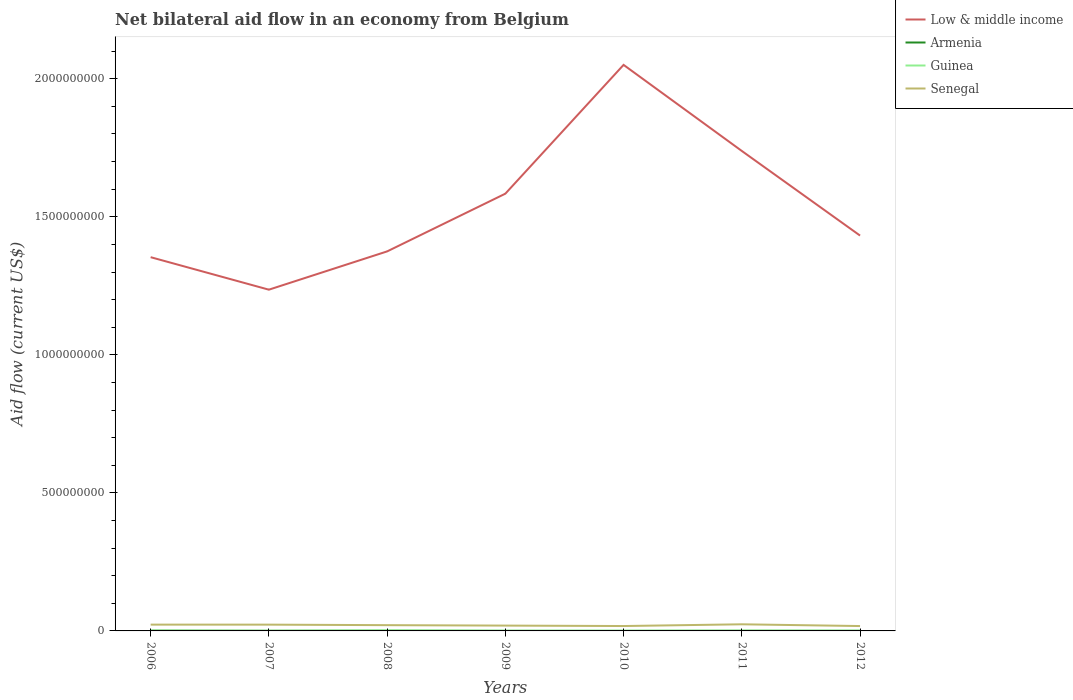Is the number of lines equal to the number of legend labels?
Ensure brevity in your answer.  Yes. Across all years, what is the maximum net bilateral aid flow in Armenia?
Your response must be concise. 3.00e+04. In which year was the net bilateral aid flow in Armenia maximum?
Make the answer very short. 2010. What is the total net bilateral aid flow in Senegal in the graph?
Your answer should be compact. 5.06e+06. What is the difference between the highest and the second highest net bilateral aid flow in Armenia?
Offer a terse response. 9.20e+05. What is the difference between the highest and the lowest net bilateral aid flow in Guinea?
Provide a succinct answer. 3. Is the net bilateral aid flow in Armenia strictly greater than the net bilateral aid flow in Low & middle income over the years?
Your answer should be very brief. Yes. How many lines are there?
Offer a terse response. 4. How many legend labels are there?
Offer a terse response. 4. What is the title of the graph?
Your answer should be compact. Net bilateral aid flow in an economy from Belgium. What is the label or title of the X-axis?
Make the answer very short. Years. What is the Aid flow (current US$) of Low & middle income in 2006?
Provide a short and direct response. 1.35e+09. What is the Aid flow (current US$) of Armenia in 2006?
Offer a terse response. 9.50e+05. What is the Aid flow (current US$) of Guinea in 2006?
Your answer should be compact. 1.53e+06. What is the Aid flow (current US$) in Senegal in 2006?
Make the answer very short. 2.28e+07. What is the Aid flow (current US$) of Low & middle income in 2007?
Make the answer very short. 1.24e+09. What is the Aid flow (current US$) in Armenia in 2007?
Your response must be concise. 3.70e+05. What is the Aid flow (current US$) in Guinea in 2007?
Give a very brief answer. 9.20e+05. What is the Aid flow (current US$) in Senegal in 2007?
Your response must be concise. 2.28e+07. What is the Aid flow (current US$) in Low & middle income in 2008?
Give a very brief answer. 1.37e+09. What is the Aid flow (current US$) in Armenia in 2008?
Give a very brief answer. 6.50e+05. What is the Aid flow (current US$) in Guinea in 2008?
Ensure brevity in your answer.  2.24e+06. What is the Aid flow (current US$) in Senegal in 2008?
Provide a succinct answer. 2.09e+07. What is the Aid flow (current US$) of Low & middle income in 2009?
Provide a succinct answer. 1.58e+09. What is the Aid flow (current US$) in Guinea in 2009?
Make the answer very short. 1.15e+06. What is the Aid flow (current US$) of Senegal in 2009?
Your response must be concise. 1.93e+07. What is the Aid flow (current US$) in Low & middle income in 2010?
Offer a very short reply. 2.05e+09. What is the Aid flow (current US$) in Armenia in 2010?
Make the answer very short. 3.00e+04. What is the Aid flow (current US$) of Guinea in 2010?
Keep it short and to the point. 1.05e+06. What is the Aid flow (current US$) in Senegal in 2010?
Give a very brief answer. 1.77e+07. What is the Aid flow (current US$) in Low & middle income in 2011?
Offer a terse response. 1.74e+09. What is the Aid flow (current US$) in Armenia in 2011?
Your response must be concise. 3.70e+05. What is the Aid flow (current US$) in Guinea in 2011?
Your answer should be very brief. 1.47e+06. What is the Aid flow (current US$) in Senegal in 2011?
Your response must be concise. 2.40e+07. What is the Aid flow (current US$) in Low & middle income in 2012?
Offer a very short reply. 1.43e+09. What is the Aid flow (current US$) in Armenia in 2012?
Offer a very short reply. 2.00e+05. What is the Aid flow (current US$) of Guinea in 2012?
Offer a very short reply. 1.37e+06. What is the Aid flow (current US$) of Senegal in 2012?
Give a very brief answer. 1.77e+07. Across all years, what is the maximum Aid flow (current US$) of Low & middle income?
Make the answer very short. 2.05e+09. Across all years, what is the maximum Aid flow (current US$) in Armenia?
Your response must be concise. 9.50e+05. Across all years, what is the maximum Aid flow (current US$) of Guinea?
Your response must be concise. 2.24e+06. Across all years, what is the maximum Aid flow (current US$) of Senegal?
Your response must be concise. 2.40e+07. Across all years, what is the minimum Aid flow (current US$) in Low & middle income?
Offer a very short reply. 1.24e+09. Across all years, what is the minimum Aid flow (current US$) in Guinea?
Offer a terse response. 9.20e+05. Across all years, what is the minimum Aid flow (current US$) in Senegal?
Your answer should be compact. 1.77e+07. What is the total Aid flow (current US$) in Low & middle income in the graph?
Keep it short and to the point. 1.08e+1. What is the total Aid flow (current US$) of Armenia in the graph?
Your response must be concise. 2.67e+06. What is the total Aid flow (current US$) in Guinea in the graph?
Offer a terse response. 9.73e+06. What is the total Aid flow (current US$) of Senegal in the graph?
Provide a short and direct response. 1.45e+08. What is the difference between the Aid flow (current US$) in Low & middle income in 2006 and that in 2007?
Provide a succinct answer. 1.18e+08. What is the difference between the Aid flow (current US$) in Armenia in 2006 and that in 2007?
Give a very brief answer. 5.80e+05. What is the difference between the Aid flow (current US$) in Guinea in 2006 and that in 2007?
Your answer should be very brief. 6.10e+05. What is the difference between the Aid flow (current US$) in Low & middle income in 2006 and that in 2008?
Offer a terse response. -2.09e+07. What is the difference between the Aid flow (current US$) in Guinea in 2006 and that in 2008?
Make the answer very short. -7.10e+05. What is the difference between the Aid flow (current US$) of Senegal in 2006 and that in 2008?
Keep it short and to the point. 1.89e+06. What is the difference between the Aid flow (current US$) of Low & middle income in 2006 and that in 2009?
Ensure brevity in your answer.  -2.30e+08. What is the difference between the Aid flow (current US$) of Armenia in 2006 and that in 2009?
Offer a very short reply. 8.50e+05. What is the difference between the Aid flow (current US$) in Senegal in 2006 and that in 2009?
Give a very brief answer. 3.50e+06. What is the difference between the Aid flow (current US$) of Low & middle income in 2006 and that in 2010?
Your answer should be very brief. -6.97e+08. What is the difference between the Aid flow (current US$) in Armenia in 2006 and that in 2010?
Make the answer very short. 9.20e+05. What is the difference between the Aid flow (current US$) of Guinea in 2006 and that in 2010?
Ensure brevity in your answer.  4.80e+05. What is the difference between the Aid flow (current US$) in Senegal in 2006 and that in 2010?
Provide a short and direct response. 5.06e+06. What is the difference between the Aid flow (current US$) in Low & middle income in 2006 and that in 2011?
Offer a very short reply. -3.85e+08. What is the difference between the Aid flow (current US$) in Armenia in 2006 and that in 2011?
Offer a very short reply. 5.80e+05. What is the difference between the Aid flow (current US$) of Senegal in 2006 and that in 2011?
Give a very brief answer. -1.18e+06. What is the difference between the Aid flow (current US$) of Low & middle income in 2006 and that in 2012?
Offer a very short reply. -7.82e+07. What is the difference between the Aid flow (current US$) of Armenia in 2006 and that in 2012?
Offer a terse response. 7.50e+05. What is the difference between the Aid flow (current US$) of Guinea in 2006 and that in 2012?
Keep it short and to the point. 1.60e+05. What is the difference between the Aid flow (current US$) of Senegal in 2006 and that in 2012?
Your answer should be very brief. 5.13e+06. What is the difference between the Aid flow (current US$) of Low & middle income in 2007 and that in 2008?
Ensure brevity in your answer.  -1.39e+08. What is the difference between the Aid flow (current US$) in Armenia in 2007 and that in 2008?
Your answer should be compact. -2.80e+05. What is the difference between the Aid flow (current US$) in Guinea in 2007 and that in 2008?
Offer a terse response. -1.32e+06. What is the difference between the Aid flow (current US$) in Senegal in 2007 and that in 2008?
Your answer should be very brief. 1.84e+06. What is the difference between the Aid flow (current US$) of Low & middle income in 2007 and that in 2009?
Give a very brief answer. -3.48e+08. What is the difference between the Aid flow (current US$) of Armenia in 2007 and that in 2009?
Ensure brevity in your answer.  2.70e+05. What is the difference between the Aid flow (current US$) of Guinea in 2007 and that in 2009?
Keep it short and to the point. -2.30e+05. What is the difference between the Aid flow (current US$) of Senegal in 2007 and that in 2009?
Your answer should be compact. 3.45e+06. What is the difference between the Aid flow (current US$) of Low & middle income in 2007 and that in 2010?
Provide a short and direct response. -8.14e+08. What is the difference between the Aid flow (current US$) in Armenia in 2007 and that in 2010?
Your response must be concise. 3.40e+05. What is the difference between the Aid flow (current US$) of Senegal in 2007 and that in 2010?
Keep it short and to the point. 5.01e+06. What is the difference between the Aid flow (current US$) in Low & middle income in 2007 and that in 2011?
Provide a short and direct response. -5.02e+08. What is the difference between the Aid flow (current US$) in Armenia in 2007 and that in 2011?
Provide a succinct answer. 0. What is the difference between the Aid flow (current US$) of Guinea in 2007 and that in 2011?
Ensure brevity in your answer.  -5.50e+05. What is the difference between the Aid flow (current US$) in Senegal in 2007 and that in 2011?
Provide a short and direct response. -1.23e+06. What is the difference between the Aid flow (current US$) of Low & middle income in 2007 and that in 2012?
Offer a very short reply. -1.96e+08. What is the difference between the Aid flow (current US$) in Guinea in 2007 and that in 2012?
Offer a terse response. -4.50e+05. What is the difference between the Aid flow (current US$) of Senegal in 2007 and that in 2012?
Your response must be concise. 5.08e+06. What is the difference between the Aid flow (current US$) of Low & middle income in 2008 and that in 2009?
Your answer should be compact. -2.09e+08. What is the difference between the Aid flow (current US$) of Guinea in 2008 and that in 2009?
Your answer should be compact. 1.09e+06. What is the difference between the Aid flow (current US$) of Senegal in 2008 and that in 2009?
Keep it short and to the point. 1.61e+06. What is the difference between the Aid flow (current US$) in Low & middle income in 2008 and that in 2010?
Your answer should be compact. -6.76e+08. What is the difference between the Aid flow (current US$) of Armenia in 2008 and that in 2010?
Offer a terse response. 6.20e+05. What is the difference between the Aid flow (current US$) of Guinea in 2008 and that in 2010?
Provide a succinct answer. 1.19e+06. What is the difference between the Aid flow (current US$) in Senegal in 2008 and that in 2010?
Offer a terse response. 3.17e+06. What is the difference between the Aid flow (current US$) of Low & middle income in 2008 and that in 2011?
Keep it short and to the point. -3.64e+08. What is the difference between the Aid flow (current US$) in Guinea in 2008 and that in 2011?
Your answer should be very brief. 7.70e+05. What is the difference between the Aid flow (current US$) in Senegal in 2008 and that in 2011?
Make the answer very short. -3.07e+06. What is the difference between the Aid flow (current US$) of Low & middle income in 2008 and that in 2012?
Offer a terse response. -5.73e+07. What is the difference between the Aid flow (current US$) of Guinea in 2008 and that in 2012?
Keep it short and to the point. 8.70e+05. What is the difference between the Aid flow (current US$) of Senegal in 2008 and that in 2012?
Keep it short and to the point. 3.24e+06. What is the difference between the Aid flow (current US$) in Low & middle income in 2009 and that in 2010?
Provide a succinct answer. -4.67e+08. What is the difference between the Aid flow (current US$) of Guinea in 2009 and that in 2010?
Your response must be concise. 1.00e+05. What is the difference between the Aid flow (current US$) of Senegal in 2009 and that in 2010?
Your response must be concise. 1.56e+06. What is the difference between the Aid flow (current US$) in Low & middle income in 2009 and that in 2011?
Your response must be concise. -1.55e+08. What is the difference between the Aid flow (current US$) of Armenia in 2009 and that in 2011?
Offer a very short reply. -2.70e+05. What is the difference between the Aid flow (current US$) in Guinea in 2009 and that in 2011?
Offer a very short reply. -3.20e+05. What is the difference between the Aid flow (current US$) of Senegal in 2009 and that in 2011?
Your answer should be very brief. -4.68e+06. What is the difference between the Aid flow (current US$) in Low & middle income in 2009 and that in 2012?
Your answer should be compact. 1.52e+08. What is the difference between the Aid flow (current US$) in Armenia in 2009 and that in 2012?
Ensure brevity in your answer.  -1.00e+05. What is the difference between the Aid flow (current US$) of Guinea in 2009 and that in 2012?
Ensure brevity in your answer.  -2.20e+05. What is the difference between the Aid flow (current US$) of Senegal in 2009 and that in 2012?
Your answer should be very brief. 1.63e+06. What is the difference between the Aid flow (current US$) in Low & middle income in 2010 and that in 2011?
Keep it short and to the point. 3.12e+08. What is the difference between the Aid flow (current US$) of Guinea in 2010 and that in 2011?
Your response must be concise. -4.20e+05. What is the difference between the Aid flow (current US$) in Senegal in 2010 and that in 2011?
Offer a terse response. -6.24e+06. What is the difference between the Aid flow (current US$) of Low & middle income in 2010 and that in 2012?
Provide a short and direct response. 6.18e+08. What is the difference between the Aid flow (current US$) in Guinea in 2010 and that in 2012?
Ensure brevity in your answer.  -3.20e+05. What is the difference between the Aid flow (current US$) in Low & middle income in 2011 and that in 2012?
Your response must be concise. 3.07e+08. What is the difference between the Aid flow (current US$) in Armenia in 2011 and that in 2012?
Give a very brief answer. 1.70e+05. What is the difference between the Aid flow (current US$) in Senegal in 2011 and that in 2012?
Give a very brief answer. 6.31e+06. What is the difference between the Aid flow (current US$) of Low & middle income in 2006 and the Aid flow (current US$) of Armenia in 2007?
Your response must be concise. 1.35e+09. What is the difference between the Aid flow (current US$) in Low & middle income in 2006 and the Aid flow (current US$) in Guinea in 2007?
Your response must be concise. 1.35e+09. What is the difference between the Aid flow (current US$) of Low & middle income in 2006 and the Aid flow (current US$) of Senegal in 2007?
Give a very brief answer. 1.33e+09. What is the difference between the Aid flow (current US$) in Armenia in 2006 and the Aid flow (current US$) in Senegal in 2007?
Offer a terse response. -2.18e+07. What is the difference between the Aid flow (current US$) in Guinea in 2006 and the Aid flow (current US$) in Senegal in 2007?
Keep it short and to the point. -2.12e+07. What is the difference between the Aid flow (current US$) in Low & middle income in 2006 and the Aid flow (current US$) in Armenia in 2008?
Your answer should be compact. 1.35e+09. What is the difference between the Aid flow (current US$) of Low & middle income in 2006 and the Aid flow (current US$) of Guinea in 2008?
Offer a terse response. 1.35e+09. What is the difference between the Aid flow (current US$) of Low & middle income in 2006 and the Aid flow (current US$) of Senegal in 2008?
Provide a short and direct response. 1.33e+09. What is the difference between the Aid flow (current US$) of Armenia in 2006 and the Aid flow (current US$) of Guinea in 2008?
Give a very brief answer. -1.29e+06. What is the difference between the Aid flow (current US$) in Armenia in 2006 and the Aid flow (current US$) in Senegal in 2008?
Your answer should be very brief. -2.00e+07. What is the difference between the Aid flow (current US$) in Guinea in 2006 and the Aid flow (current US$) in Senegal in 2008?
Provide a short and direct response. -1.94e+07. What is the difference between the Aid flow (current US$) in Low & middle income in 2006 and the Aid flow (current US$) in Armenia in 2009?
Keep it short and to the point. 1.35e+09. What is the difference between the Aid flow (current US$) in Low & middle income in 2006 and the Aid flow (current US$) in Guinea in 2009?
Your answer should be very brief. 1.35e+09. What is the difference between the Aid flow (current US$) of Low & middle income in 2006 and the Aid flow (current US$) of Senegal in 2009?
Ensure brevity in your answer.  1.33e+09. What is the difference between the Aid flow (current US$) of Armenia in 2006 and the Aid flow (current US$) of Guinea in 2009?
Provide a succinct answer. -2.00e+05. What is the difference between the Aid flow (current US$) in Armenia in 2006 and the Aid flow (current US$) in Senegal in 2009?
Keep it short and to the point. -1.84e+07. What is the difference between the Aid flow (current US$) in Guinea in 2006 and the Aid flow (current US$) in Senegal in 2009?
Ensure brevity in your answer.  -1.78e+07. What is the difference between the Aid flow (current US$) in Low & middle income in 2006 and the Aid flow (current US$) in Armenia in 2010?
Your response must be concise. 1.35e+09. What is the difference between the Aid flow (current US$) in Low & middle income in 2006 and the Aid flow (current US$) in Guinea in 2010?
Your answer should be compact. 1.35e+09. What is the difference between the Aid flow (current US$) of Low & middle income in 2006 and the Aid flow (current US$) of Senegal in 2010?
Your answer should be compact. 1.34e+09. What is the difference between the Aid flow (current US$) of Armenia in 2006 and the Aid flow (current US$) of Guinea in 2010?
Your answer should be compact. -1.00e+05. What is the difference between the Aid flow (current US$) in Armenia in 2006 and the Aid flow (current US$) in Senegal in 2010?
Offer a very short reply. -1.68e+07. What is the difference between the Aid flow (current US$) in Guinea in 2006 and the Aid flow (current US$) in Senegal in 2010?
Your answer should be very brief. -1.62e+07. What is the difference between the Aid flow (current US$) of Low & middle income in 2006 and the Aid flow (current US$) of Armenia in 2011?
Your answer should be very brief. 1.35e+09. What is the difference between the Aid flow (current US$) in Low & middle income in 2006 and the Aid flow (current US$) in Guinea in 2011?
Offer a terse response. 1.35e+09. What is the difference between the Aid flow (current US$) in Low & middle income in 2006 and the Aid flow (current US$) in Senegal in 2011?
Provide a short and direct response. 1.33e+09. What is the difference between the Aid flow (current US$) in Armenia in 2006 and the Aid flow (current US$) in Guinea in 2011?
Your response must be concise. -5.20e+05. What is the difference between the Aid flow (current US$) of Armenia in 2006 and the Aid flow (current US$) of Senegal in 2011?
Ensure brevity in your answer.  -2.30e+07. What is the difference between the Aid flow (current US$) in Guinea in 2006 and the Aid flow (current US$) in Senegal in 2011?
Your answer should be compact. -2.24e+07. What is the difference between the Aid flow (current US$) of Low & middle income in 2006 and the Aid flow (current US$) of Armenia in 2012?
Ensure brevity in your answer.  1.35e+09. What is the difference between the Aid flow (current US$) in Low & middle income in 2006 and the Aid flow (current US$) in Guinea in 2012?
Provide a short and direct response. 1.35e+09. What is the difference between the Aid flow (current US$) of Low & middle income in 2006 and the Aid flow (current US$) of Senegal in 2012?
Give a very brief answer. 1.34e+09. What is the difference between the Aid flow (current US$) of Armenia in 2006 and the Aid flow (current US$) of Guinea in 2012?
Make the answer very short. -4.20e+05. What is the difference between the Aid flow (current US$) in Armenia in 2006 and the Aid flow (current US$) in Senegal in 2012?
Ensure brevity in your answer.  -1.67e+07. What is the difference between the Aid flow (current US$) of Guinea in 2006 and the Aid flow (current US$) of Senegal in 2012?
Offer a very short reply. -1.61e+07. What is the difference between the Aid flow (current US$) of Low & middle income in 2007 and the Aid flow (current US$) of Armenia in 2008?
Offer a very short reply. 1.24e+09. What is the difference between the Aid flow (current US$) in Low & middle income in 2007 and the Aid flow (current US$) in Guinea in 2008?
Make the answer very short. 1.23e+09. What is the difference between the Aid flow (current US$) in Low & middle income in 2007 and the Aid flow (current US$) in Senegal in 2008?
Your response must be concise. 1.22e+09. What is the difference between the Aid flow (current US$) in Armenia in 2007 and the Aid flow (current US$) in Guinea in 2008?
Offer a very short reply. -1.87e+06. What is the difference between the Aid flow (current US$) in Armenia in 2007 and the Aid flow (current US$) in Senegal in 2008?
Keep it short and to the point. -2.05e+07. What is the difference between the Aid flow (current US$) in Guinea in 2007 and the Aid flow (current US$) in Senegal in 2008?
Your response must be concise. -2.00e+07. What is the difference between the Aid flow (current US$) of Low & middle income in 2007 and the Aid flow (current US$) of Armenia in 2009?
Provide a succinct answer. 1.24e+09. What is the difference between the Aid flow (current US$) in Low & middle income in 2007 and the Aid flow (current US$) in Guinea in 2009?
Offer a very short reply. 1.23e+09. What is the difference between the Aid flow (current US$) of Low & middle income in 2007 and the Aid flow (current US$) of Senegal in 2009?
Offer a very short reply. 1.22e+09. What is the difference between the Aid flow (current US$) in Armenia in 2007 and the Aid flow (current US$) in Guinea in 2009?
Make the answer very short. -7.80e+05. What is the difference between the Aid flow (current US$) of Armenia in 2007 and the Aid flow (current US$) of Senegal in 2009?
Provide a succinct answer. -1.89e+07. What is the difference between the Aid flow (current US$) of Guinea in 2007 and the Aid flow (current US$) of Senegal in 2009?
Your answer should be very brief. -1.84e+07. What is the difference between the Aid flow (current US$) in Low & middle income in 2007 and the Aid flow (current US$) in Armenia in 2010?
Give a very brief answer. 1.24e+09. What is the difference between the Aid flow (current US$) of Low & middle income in 2007 and the Aid flow (current US$) of Guinea in 2010?
Offer a terse response. 1.24e+09. What is the difference between the Aid flow (current US$) of Low & middle income in 2007 and the Aid flow (current US$) of Senegal in 2010?
Offer a terse response. 1.22e+09. What is the difference between the Aid flow (current US$) of Armenia in 2007 and the Aid flow (current US$) of Guinea in 2010?
Offer a very short reply. -6.80e+05. What is the difference between the Aid flow (current US$) in Armenia in 2007 and the Aid flow (current US$) in Senegal in 2010?
Keep it short and to the point. -1.74e+07. What is the difference between the Aid flow (current US$) in Guinea in 2007 and the Aid flow (current US$) in Senegal in 2010?
Offer a very short reply. -1.68e+07. What is the difference between the Aid flow (current US$) of Low & middle income in 2007 and the Aid flow (current US$) of Armenia in 2011?
Give a very brief answer. 1.24e+09. What is the difference between the Aid flow (current US$) in Low & middle income in 2007 and the Aid flow (current US$) in Guinea in 2011?
Offer a terse response. 1.23e+09. What is the difference between the Aid flow (current US$) of Low & middle income in 2007 and the Aid flow (current US$) of Senegal in 2011?
Offer a very short reply. 1.21e+09. What is the difference between the Aid flow (current US$) in Armenia in 2007 and the Aid flow (current US$) in Guinea in 2011?
Offer a very short reply. -1.10e+06. What is the difference between the Aid flow (current US$) in Armenia in 2007 and the Aid flow (current US$) in Senegal in 2011?
Give a very brief answer. -2.36e+07. What is the difference between the Aid flow (current US$) of Guinea in 2007 and the Aid flow (current US$) of Senegal in 2011?
Offer a very short reply. -2.31e+07. What is the difference between the Aid flow (current US$) in Low & middle income in 2007 and the Aid flow (current US$) in Armenia in 2012?
Your response must be concise. 1.24e+09. What is the difference between the Aid flow (current US$) of Low & middle income in 2007 and the Aid flow (current US$) of Guinea in 2012?
Keep it short and to the point. 1.23e+09. What is the difference between the Aid flow (current US$) in Low & middle income in 2007 and the Aid flow (current US$) in Senegal in 2012?
Provide a succinct answer. 1.22e+09. What is the difference between the Aid flow (current US$) of Armenia in 2007 and the Aid flow (current US$) of Senegal in 2012?
Your answer should be very brief. -1.73e+07. What is the difference between the Aid flow (current US$) in Guinea in 2007 and the Aid flow (current US$) in Senegal in 2012?
Offer a very short reply. -1.68e+07. What is the difference between the Aid flow (current US$) in Low & middle income in 2008 and the Aid flow (current US$) in Armenia in 2009?
Make the answer very short. 1.37e+09. What is the difference between the Aid flow (current US$) in Low & middle income in 2008 and the Aid flow (current US$) in Guinea in 2009?
Your response must be concise. 1.37e+09. What is the difference between the Aid flow (current US$) in Low & middle income in 2008 and the Aid flow (current US$) in Senegal in 2009?
Keep it short and to the point. 1.36e+09. What is the difference between the Aid flow (current US$) in Armenia in 2008 and the Aid flow (current US$) in Guinea in 2009?
Your answer should be compact. -5.00e+05. What is the difference between the Aid flow (current US$) of Armenia in 2008 and the Aid flow (current US$) of Senegal in 2009?
Provide a succinct answer. -1.86e+07. What is the difference between the Aid flow (current US$) in Guinea in 2008 and the Aid flow (current US$) in Senegal in 2009?
Ensure brevity in your answer.  -1.71e+07. What is the difference between the Aid flow (current US$) of Low & middle income in 2008 and the Aid flow (current US$) of Armenia in 2010?
Provide a short and direct response. 1.37e+09. What is the difference between the Aid flow (current US$) of Low & middle income in 2008 and the Aid flow (current US$) of Guinea in 2010?
Provide a succinct answer. 1.37e+09. What is the difference between the Aid flow (current US$) in Low & middle income in 2008 and the Aid flow (current US$) in Senegal in 2010?
Offer a terse response. 1.36e+09. What is the difference between the Aid flow (current US$) of Armenia in 2008 and the Aid flow (current US$) of Guinea in 2010?
Offer a very short reply. -4.00e+05. What is the difference between the Aid flow (current US$) of Armenia in 2008 and the Aid flow (current US$) of Senegal in 2010?
Give a very brief answer. -1.71e+07. What is the difference between the Aid flow (current US$) of Guinea in 2008 and the Aid flow (current US$) of Senegal in 2010?
Your answer should be very brief. -1.55e+07. What is the difference between the Aid flow (current US$) of Low & middle income in 2008 and the Aid flow (current US$) of Armenia in 2011?
Keep it short and to the point. 1.37e+09. What is the difference between the Aid flow (current US$) in Low & middle income in 2008 and the Aid flow (current US$) in Guinea in 2011?
Offer a terse response. 1.37e+09. What is the difference between the Aid flow (current US$) of Low & middle income in 2008 and the Aid flow (current US$) of Senegal in 2011?
Keep it short and to the point. 1.35e+09. What is the difference between the Aid flow (current US$) in Armenia in 2008 and the Aid flow (current US$) in Guinea in 2011?
Make the answer very short. -8.20e+05. What is the difference between the Aid flow (current US$) in Armenia in 2008 and the Aid flow (current US$) in Senegal in 2011?
Your answer should be compact. -2.33e+07. What is the difference between the Aid flow (current US$) in Guinea in 2008 and the Aid flow (current US$) in Senegal in 2011?
Make the answer very short. -2.17e+07. What is the difference between the Aid flow (current US$) of Low & middle income in 2008 and the Aid flow (current US$) of Armenia in 2012?
Your answer should be very brief. 1.37e+09. What is the difference between the Aid flow (current US$) in Low & middle income in 2008 and the Aid flow (current US$) in Guinea in 2012?
Provide a succinct answer. 1.37e+09. What is the difference between the Aid flow (current US$) in Low & middle income in 2008 and the Aid flow (current US$) in Senegal in 2012?
Keep it short and to the point. 1.36e+09. What is the difference between the Aid flow (current US$) of Armenia in 2008 and the Aid flow (current US$) of Guinea in 2012?
Ensure brevity in your answer.  -7.20e+05. What is the difference between the Aid flow (current US$) of Armenia in 2008 and the Aid flow (current US$) of Senegal in 2012?
Your response must be concise. -1.70e+07. What is the difference between the Aid flow (current US$) of Guinea in 2008 and the Aid flow (current US$) of Senegal in 2012?
Your answer should be compact. -1.54e+07. What is the difference between the Aid flow (current US$) in Low & middle income in 2009 and the Aid flow (current US$) in Armenia in 2010?
Offer a very short reply. 1.58e+09. What is the difference between the Aid flow (current US$) of Low & middle income in 2009 and the Aid flow (current US$) of Guinea in 2010?
Provide a short and direct response. 1.58e+09. What is the difference between the Aid flow (current US$) of Low & middle income in 2009 and the Aid flow (current US$) of Senegal in 2010?
Provide a short and direct response. 1.57e+09. What is the difference between the Aid flow (current US$) in Armenia in 2009 and the Aid flow (current US$) in Guinea in 2010?
Ensure brevity in your answer.  -9.50e+05. What is the difference between the Aid flow (current US$) of Armenia in 2009 and the Aid flow (current US$) of Senegal in 2010?
Keep it short and to the point. -1.76e+07. What is the difference between the Aid flow (current US$) in Guinea in 2009 and the Aid flow (current US$) in Senegal in 2010?
Offer a terse response. -1.66e+07. What is the difference between the Aid flow (current US$) in Low & middle income in 2009 and the Aid flow (current US$) in Armenia in 2011?
Make the answer very short. 1.58e+09. What is the difference between the Aid flow (current US$) of Low & middle income in 2009 and the Aid flow (current US$) of Guinea in 2011?
Provide a succinct answer. 1.58e+09. What is the difference between the Aid flow (current US$) in Low & middle income in 2009 and the Aid flow (current US$) in Senegal in 2011?
Make the answer very short. 1.56e+09. What is the difference between the Aid flow (current US$) of Armenia in 2009 and the Aid flow (current US$) of Guinea in 2011?
Offer a very short reply. -1.37e+06. What is the difference between the Aid flow (current US$) of Armenia in 2009 and the Aid flow (current US$) of Senegal in 2011?
Provide a short and direct response. -2.39e+07. What is the difference between the Aid flow (current US$) in Guinea in 2009 and the Aid flow (current US$) in Senegal in 2011?
Provide a short and direct response. -2.28e+07. What is the difference between the Aid flow (current US$) in Low & middle income in 2009 and the Aid flow (current US$) in Armenia in 2012?
Give a very brief answer. 1.58e+09. What is the difference between the Aid flow (current US$) of Low & middle income in 2009 and the Aid flow (current US$) of Guinea in 2012?
Ensure brevity in your answer.  1.58e+09. What is the difference between the Aid flow (current US$) of Low & middle income in 2009 and the Aid flow (current US$) of Senegal in 2012?
Your answer should be compact. 1.57e+09. What is the difference between the Aid flow (current US$) in Armenia in 2009 and the Aid flow (current US$) in Guinea in 2012?
Your response must be concise. -1.27e+06. What is the difference between the Aid flow (current US$) of Armenia in 2009 and the Aid flow (current US$) of Senegal in 2012?
Offer a very short reply. -1.76e+07. What is the difference between the Aid flow (current US$) of Guinea in 2009 and the Aid flow (current US$) of Senegal in 2012?
Make the answer very short. -1.65e+07. What is the difference between the Aid flow (current US$) in Low & middle income in 2010 and the Aid flow (current US$) in Armenia in 2011?
Ensure brevity in your answer.  2.05e+09. What is the difference between the Aid flow (current US$) of Low & middle income in 2010 and the Aid flow (current US$) of Guinea in 2011?
Provide a short and direct response. 2.05e+09. What is the difference between the Aid flow (current US$) of Low & middle income in 2010 and the Aid flow (current US$) of Senegal in 2011?
Provide a succinct answer. 2.03e+09. What is the difference between the Aid flow (current US$) of Armenia in 2010 and the Aid flow (current US$) of Guinea in 2011?
Provide a succinct answer. -1.44e+06. What is the difference between the Aid flow (current US$) in Armenia in 2010 and the Aid flow (current US$) in Senegal in 2011?
Provide a short and direct response. -2.40e+07. What is the difference between the Aid flow (current US$) of Guinea in 2010 and the Aid flow (current US$) of Senegal in 2011?
Offer a terse response. -2.29e+07. What is the difference between the Aid flow (current US$) in Low & middle income in 2010 and the Aid flow (current US$) in Armenia in 2012?
Ensure brevity in your answer.  2.05e+09. What is the difference between the Aid flow (current US$) of Low & middle income in 2010 and the Aid flow (current US$) of Guinea in 2012?
Give a very brief answer. 2.05e+09. What is the difference between the Aid flow (current US$) of Low & middle income in 2010 and the Aid flow (current US$) of Senegal in 2012?
Offer a very short reply. 2.03e+09. What is the difference between the Aid flow (current US$) in Armenia in 2010 and the Aid flow (current US$) in Guinea in 2012?
Ensure brevity in your answer.  -1.34e+06. What is the difference between the Aid flow (current US$) of Armenia in 2010 and the Aid flow (current US$) of Senegal in 2012?
Provide a short and direct response. -1.76e+07. What is the difference between the Aid flow (current US$) of Guinea in 2010 and the Aid flow (current US$) of Senegal in 2012?
Provide a succinct answer. -1.66e+07. What is the difference between the Aid flow (current US$) of Low & middle income in 2011 and the Aid flow (current US$) of Armenia in 2012?
Give a very brief answer. 1.74e+09. What is the difference between the Aid flow (current US$) of Low & middle income in 2011 and the Aid flow (current US$) of Guinea in 2012?
Make the answer very short. 1.74e+09. What is the difference between the Aid flow (current US$) in Low & middle income in 2011 and the Aid flow (current US$) in Senegal in 2012?
Your answer should be compact. 1.72e+09. What is the difference between the Aid flow (current US$) of Armenia in 2011 and the Aid flow (current US$) of Guinea in 2012?
Keep it short and to the point. -1.00e+06. What is the difference between the Aid flow (current US$) in Armenia in 2011 and the Aid flow (current US$) in Senegal in 2012?
Your response must be concise. -1.73e+07. What is the difference between the Aid flow (current US$) in Guinea in 2011 and the Aid flow (current US$) in Senegal in 2012?
Your response must be concise. -1.62e+07. What is the average Aid flow (current US$) in Low & middle income per year?
Your answer should be compact. 1.54e+09. What is the average Aid flow (current US$) in Armenia per year?
Your answer should be very brief. 3.81e+05. What is the average Aid flow (current US$) of Guinea per year?
Offer a very short reply. 1.39e+06. What is the average Aid flow (current US$) in Senegal per year?
Your answer should be compact. 2.07e+07. In the year 2006, what is the difference between the Aid flow (current US$) in Low & middle income and Aid flow (current US$) in Armenia?
Give a very brief answer. 1.35e+09. In the year 2006, what is the difference between the Aid flow (current US$) of Low & middle income and Aid flow (current US$) of Guinea?
Your answer should be compact. 1.35e+09. In the year 2006, what is the difference between the Aid flow (current US$) of Low & middle income and Aid flow (current US$) of Senegal?
Offer a terse response. 1.33e+09. In the year 2006, what is the difference between the Aid flow (current US$) of Armenia and Aid flow (current US$) of Guinea?
Provide a succinct answer. -5.80e+05. In the year 2006, what is the difference between the Aid flow (current US$) of Armenia and Aid flow (current US$) of Senegal?
Ensure brevity in your answer.  -2.18e+07. In the year 2006, what is the difference between the Aid flow (current US$) of Guinea and Aid flow (current US$) of Senegal?
Your response must be concise. -2.13e+07. In the year 2007, what is the difference between the Aid flow (current US$) in Low & middle income and Aid flow (current US$) in Armenia?
Give a very brief answer. 1.24e+09. In the year 2007, what is the difference between the Aid flow (current US$) in Low & middle income and Aid flow (current US$) in Guinea?
Provide a short and direct response. 1.24e+09. In the year 2007, what is the difference between the Aid flow (current US$) in Low & middle income and Aid flow (current US$) in Senegal?
Offer a terse response. 1.21e+09. In the year 2007, what is the difference between the Aid flow (current US$) of Armenia and Aid flow (current US$) of Guinea?
Offer a terse response. -5.50e+05. In the year 2007, what is the difference between the Aid flow (current US$) in Armenia and Aid flow (current US$) in Senegal?
Provide a short and direct response. -2.24e+07. In the year 2007, what is the difference between the Aid flow (current US$) in Guinea and Aid flow (current US$) in Senegal?
Keep it short and to the point. -2.18e+07. In the year 2008, what is the difference between the Aid flow (current US$) of Low & middle income and Aid flow (current US$) of Armenia?
Provide a short and direct response. 1.37e+09. In the year 2008, what is the difference between the Aid flow (current US$) in Low & middle income and Aid flow (current US$) in Guinea?
Make the answer very short. 1.37e+09. In the year 2008, what is the difference between the Aid flow (current US$) of Low & middle income and Aid flow (current US$) of Senegal?
Offer a terse response. 1.35e+09. In the year 2008, what is the difference between the Aid flow (current US$) of Armenia and Aid flow (current US$) of Guinea?
Your answer should be compact. -1.59e+06. In the year 2008, what is the difference between the Aid flow (current US$) in Armenia and Aid flow (current US$) in Senegal?
Make the answer very short. -2.03e+07. In the year 2008, what is the difference between the Aid flow (current US$) in Guinea and Aid flow (current US$) in Senegal?
Provide a short and direct response. -1.87e+07. In the year 2009, what is the difference between the Aid flow (current US$) of Low & middle income and Aid flow (current US$) of Armenia?
Provide a short and direct response. 1.58e+09. In the year 2009, what is the difference between the Aid flow (current US$) of Low & middle income and Aid flow (current US$) of Guinea?
Your response must be concise. 1.58e+09. In the year 2009, what is the difference between the Aid flow (current US$) in Low & middle income and Aid flow (current US$) in Senegal?
Give a very brief answer. 1.56e+09. In the year 2009, what is the difference between the Aid flow (current US$) of Armenia and Aid flow (current US$) of Guinea?
Keep it short and to the point. -1.05e+06. In the year 2009, what is the difference between the Aid flow (current US$) in Armenia and Aid flow (current US$) in Senegal?
Your response must be concise. -1.92e+07. In the year 2009, what is the difference between the Aid flow (current US$) of Guinea and Aid flow (current US$) of Senegal?
Ensure brevity in your answer.  -1.82e+07. In the year 2010, what is the difference between the Aid flow (current US$) in Low & middle income and Aid flow (current US$) in Armenia?
Make the answer very short. 2.05e+09. In the year 2010, what is the difference between the Aid flow (current US$) in Low & middle income and Aid flow (current US$) in Guinea?
Your response must be concise. 2.05e+09. In the year 2010, what is the difference between the Aid flow (current US$) of Low & middle income and Aid flow (current US$) of Senegal?
Give a very brief answer. 2.03e+09. In the year 2010, what is the difference between the Aid flow (current US$) in Armenia and Aid flow (current US$) in Guinea?
Your response must be concise. -1.02e+06. In the year 2010, what is the difference between the Aid flow (current US$) in Armenia and Aid flow (current US$) in Senegal?
Give a very brief answer. -1.77e+07. In the year 2010, what is the difference between the Aid flow (current US$) in Guinea and Aid flow (current US$) in Senegal?
Keep it short and to the point. -1.67e+07. In the year 2011, what is the difference between the Aid flow (current US$) in Low & middle income and Aid flow (current US$) in Armenia?
Ensure brevity in your answer.  1.74e+09. In the year 2011, what is the difference between the Aid flow (current US$) in Low & middle income and Aid flow (current US$) in Guinea?
Offer a terse response. 1.74e+09. In the year 2011, what is the difference between the Aid flow (current US$) of Low & middle income and Aid flow (current US$) of Senegal?
Offer a very short reply. 1.71e+09. In the year 2011, what is the difference between the Aid flow (current US$) in Armenia and Aid flow (current US$) in Guinea?
Keep it short and to the point. -1.10e+06. In the year 2011, what is the difference between the Aid flow (current US$) in Armenia and Aid flow (current US$) in Senegal?
Ensure brevity in your answer.  -2.36e+07. In the year 2011, what is the difference between the Aid flow (current US$) in Guinea and Aid flow (current US$) in Senegal?
Your answer should be compact. -2.25e+07. In the year 2012, what is the difference between the Aid flow (current US$) of Low & middle income and Aid flow (current US$) of Armenia?
Make the answer very short. 1.43e+09. In the year 2012, what is the difference between the Aid flow (current US$) of Low & middle income and Aid flow (current US$) of Guinea?
Make the answer very short. 1.43e+09. In the year 2012, what is the difference between the Aid flow (current US$) of Low & middle income and Aid flow (current US$) of Senegal?
Your answer should be compact. 1.41e+09. In the year 2012, what is the difference between the Aid flow (current US$) in Armenia and Aid flow (current US$) in Guinea?
Offer a very short reply. -1.17e+06. In the year 2012, what is the difference between the Aid flow (current US$) in Armenia and Aid flow (current US$) in Senegal?
Your answer should be compact. -1.75e+07. In the year 2012, what is the difference between the Aid flow (current US$) in Guinea and Aid flow (current US$) in Senegal?
Offer a terse response. -1.63e+07. What is the ratio of the Aid flow (current US$) in Low & middle income in 2006 to that in 2007?
Offer a terse response. 1.1. What is the ratio of the Aid flow (current US$) of Armenia in 2006 to that in 2007?
Make the answer very short. 2.57. What is the ratio of the Aid flow (current US$) of Guinea in 2006 to that in 2007?
Offer a terse response. 1.66. What is the ratio of the Aid flow (current US$) of Senegal in 2006 to that in 2007?
Your answer should be very brief. 1. What is the ratio of the Aid flow (current US$) of Armenia in 2006 to that in 2008?
Give a very brief answer. 1.46. What is the ratio of the Aid flow (current US$) in Guinea in 2006 to that in 2008?
Your answer should be compact. 0.68. What is the ratio of the Aid flow (current US$) in Senegal in 2006 to that in 2008?
Your answer should be very brief. 1.09. What is the ratio of the Aid flow (current US$) in Low & middle income in 2006 to that in 2009?
Offer a very short reply. 0.85. What is the ratio of the Aid flow (current US$) in Guinea in 2006 to that in 2009?
Make the answer very short. 1.33. What is the ratio of the Aid flow (current US$) in Senegal in 2006 to that in 2009?
Offer a terse response. 1.18. What is the ratio of the Aid flow (current US$) of Low & middle income in 2006 to that in 2010?
Make the answer very short. 0.66. What is the ratio of the Aid flow (current US$) in Armenia in 2006 to that in 2010?
Provide a short and direct response. 31.67. What is the ratio of the Aid flow (current US$) in Guinea in 2006 to that in 2010?
Offer a terse response. 1.46. What is the ratio of the Aid flow (current US$) in Senegal in 2006 to that in 2010?
Your response must be concise. 1.29. What is the ratio of the Aid flow (current US$) of Low & middle income in 2006 to that in 2011?
Your answer should be compact. 0.78. What is the ratio of the Aid flow (current US$) of Armenia in 2006 to that in 2011?
Your answer should be very brief. 2.57. What is the ratio of the Aid flow (current US$) of Guinea in 2006 to that in 2011?
Provide a short and direct response. 1.04. What is the ratio of the Aid flow (current US$) in Senegal in 2006 to that in 2011?
Your answer should be compact. 0.95. What is the ratio of the Aid flow (current US$) of Low & middle income in 2006 to that in 2012?
Your answer should be compact. 0.95. What is the ratio of the Aid flow (current US$) in Armenia in 2006 to that in 2012?
Your response must be concise. 4.75. What is the ratio of the Aid flow (current US$) of Guinea in 2006 to that in 2012?
Provide a succinct answer. 1.12. What is the ratio of the Aid flow (current US$) in Senegal in 2006 to that in 2012?
Your response must be concise. 1.29. What is the ratio of the Aid flow (current US$) of Low & middle income in 2007 to that in 2008?
Give a very brief answer. 0.9. What is the ratio of the Aid flow (current US$) of Armenia in 2007 to that in 2008?
Offer a very short reply. 0.57. What is the ratio of the Aid flow (current US$) in Guinea in 2007 to that in 2008?
Your answer should be very brief. 0.41. What is the ratio of the Aid flow (current US$) of Senegal in 2007 to that in 2008?
Your response must be concise. 1.09. What is the ratio of the Aid flow (current US$) of Low & middle income in 2007 to that in 2009?
Your response must be concise. 0.78. What is the ratio of the Aid flow (current US$) of Senegal in 2007 to that in 2009?
Keep it short and to the point. 1.18. What is the ratio of the Aid flow (current US$) in Low & middle income in 2007 to that in 2010?
Keep it short and to the point. 0.6. What is the ratio of the Aid flow (current US$) in Armenia in 2007 to that in 2010?
Offer a terse response. 12.33. What is the ratio of the Aid flow (current US$) of Guinea in 2007 to that in 2010?
Your answer should be compact. 0.88. What is the ratio of the Aid flow (current US$) of Senegal in 2007 to that in 2010?
Make the answer very short. 1.28. What is the ratio of the Aid flow (current US$) of Low & middle income in 2007 to that in 2011?
Make the answer very short. 0.71. What is the ratio of the Aid flow (current US$) in Guinea in 2007 to that in 2011?
Keep it short and to the point. 0.63. What is the ratio of the Aid flow (current US$) of Senegal in 2007 to that in 2011?
Provide a short and direct response. 0.95. What is the ratio of the Aid flow (current US$) in Low & middle income in 2007 to that in 2012?
Offer a very short reply. 0.86. What is the ratio of the Aid flow (current US$) in Armenia in 2007 to that in 2012?
Give a very brief answer. 1.85. What is the ratio of the Aid flow (current US$) in Guinea in 2007 to that in 2012?
Offer a very short reply. 0.67. What is the ratio of the Aid flow (current US$) of Senegal in 2007 to that in 2012?
Offer a terse response. 1.29. What is the ratio of the Aid flow (current US$) of Low & middle income in 2008 to that in 2009?
Your response must be concise. 0.87. What is the ratio of the Aid flow (current US$) of Guinea in 2008 to that in 2009?
Your response must be concise. 1.95. What is the ratio of the Aid flow (current US$) in Senegal in 2008 to that in 2009?
Give a very brief answer. 1.08. What is the ratio of the Aid flow (current US$) in Low & middle income in 2008 to that in 2010?
Offer a very short reply. 0.67. What is the ratio of the Aid flow (current US$) in Armenia in 2008 to that in 2010?
Ensure brevity in your answer.  21.67. What is the ratio of the Aid flow (current US$) in Guinea in 2008 to that in 2010?
Your answer should be compact. 2.13. What is the ratio of the Aid flow (current US$) in Senegal in 2008 to that in 2010?
Provide a succinct answer. 1.18. What is the ratio of the Aid flow (current US$) in Low & middle income in 2008 to that in 2011?
Your response must be concise. 0.79. What is the ratio of the Aid flow (current US$) in Armenia in 2008 to that in 2011?
Your answer should be very brief. 1.76. What is the ratio of the Aid flow (current US$) in Guinea in 2008 to that in 2011?
Ensure brevity in your answer.  1.52. What is the ratio of the Aid flow (current US$) of Senegal in 2008 to that in 2011?
Your answer should be very brief. 0.87. What is the ratio of the Aid flow (current US$) in Guinea in 2008 to that in 2012?
Keep it short and to the point. 1.64. What is the ratio of the Aid flow (current US$) of Senegal in 2008 to that in 2012?
Ensure brevity in your answer.  1.18. What is the ratio of the Aid flow (current US$) of Low & middle income in 2009 to that in 2010?
Ensure brevity in your answer.  0.77. What is the ratio of the Aid flow (current US$) in Guinea in 2009 to that in 2010?
Offer a terse response. 1.1. What is the ratio of the Aid flow (current US$) of Senegal in 2009 to that in 2010?
Make the answer very short. 1.09. What is the ratio of the Aid flow (current US$) in Low & middle income in 2009 to that in 2011?
Your answer should be compact. 0.91. What is the ratio of the Aid flow (current US$) of Armenia in 2009 to that in 2011?
Provide a short and direct response. 0.27. What is the ratio of the Aid flow (current US$) in Guinea in 2009 to that in 2011?
Give a very brief answer. 0.78. What is the ratio of the Aid flow (current US$) in Senegal in 2009 to that in 2011?
Give a very brief answer. 0.8. What is the ratio of the Aid flow (current US$) in Low & middle income in 2009 to that in 2012?
Provide a succinct answer. 1.11. What is the ratio of the Aid flow (current US$) of Armenia in 2009 to that in 2012?
Ensure brevity in your answer.  0.5. What is the ratio of the Aid flow (current US$) of Guinea in 2009 to that in 2012?
Your answer should be very brief. 0.84. What is the ratio of the Aid flow (current US$) of Senegal in 2009 to that in 2012?
Offer a terse response. 1.09. What is the ratio of the Aid flow (current US$) in Low & middle income in 2010 to that in 2011?
Offer a very short reply. 1.18. What is the ratio of the Aid flow (current US$) in Armenia in 2010 to that in 2011?
Offer a terse response. 0.08. What is the ratio of the Aid flow (current US$) in Guinea in 2010 to that in 2011?
Offer a very short reply. 0.71. What is the ratio of the Aid flow (current US$) of Senegal in 2010 to that in 2011?
Ensure brevity in your answer.  0.74. What is the ratio of the Aid flow (current US$) in Low & middle income in 2010 to that in 2012?
Provide a short and direct response. 1.43. What is the ratio of the Aid flow (current US$) in Armenia in 2010 to that in 2012?
Give a very brief answer. 0.15. What is the ratio of the Aid flow (current US$) of Guinea in 2010 to that in 2012?
Offer a very short reply. 0.77. What is the ratio of the Aid flow (current US$) of Low & middle income in 2011 to that in 2012?
Your response must be concise. 1.21. What is the ratio of the Aid flow (current US$) in Armenia in 2011 to that in 2012?
Make the answer very short. 1.85. What is the ratio of the Aid flow (current US$) of Guinea in 2011 to that in 2012?
Your answer should be very brief. 1.07. What is the ratio of the Aid flow (current US$) in Senegal in 2011 to that in 2012?
Make the answer very short. 1.36. What is the difference between the highest and the second highest Aid flow (current US$) in Low & middle income?
Keep it short and to the point. 3.12e+08. What is the difference between the highest and the second highest Aid flow (current US$) of Armenia?
Your response must be concise. 3.00e+05. What is the difference between the highest and the second highest Aid flow (current US$) of Guinea?
Offer a very short reply. 7.10e+05. What is the difference between the highest and the second highest Aid flow (current US$) of Senegal?
Make the answer very short. 1.18e+06. What is the difference between the highest and the lowest Aid flow (current US$) of Low & middle income?
Your answer should be very brief. 8.14e+08. What is the difference between the highest and the lowest Aid flow (current US$) in Armenia?
Offer a terse response. 9.20e+05. What is the difference between the highest and the lowest Aid flow (current US$) in Guinea?
Ensure brevity in your answer.  1.32e+06. What is the difference between the highest and the lowest Aid flow (current US$) in Senegal?
Offer a very short reply. 6.31e+06. 